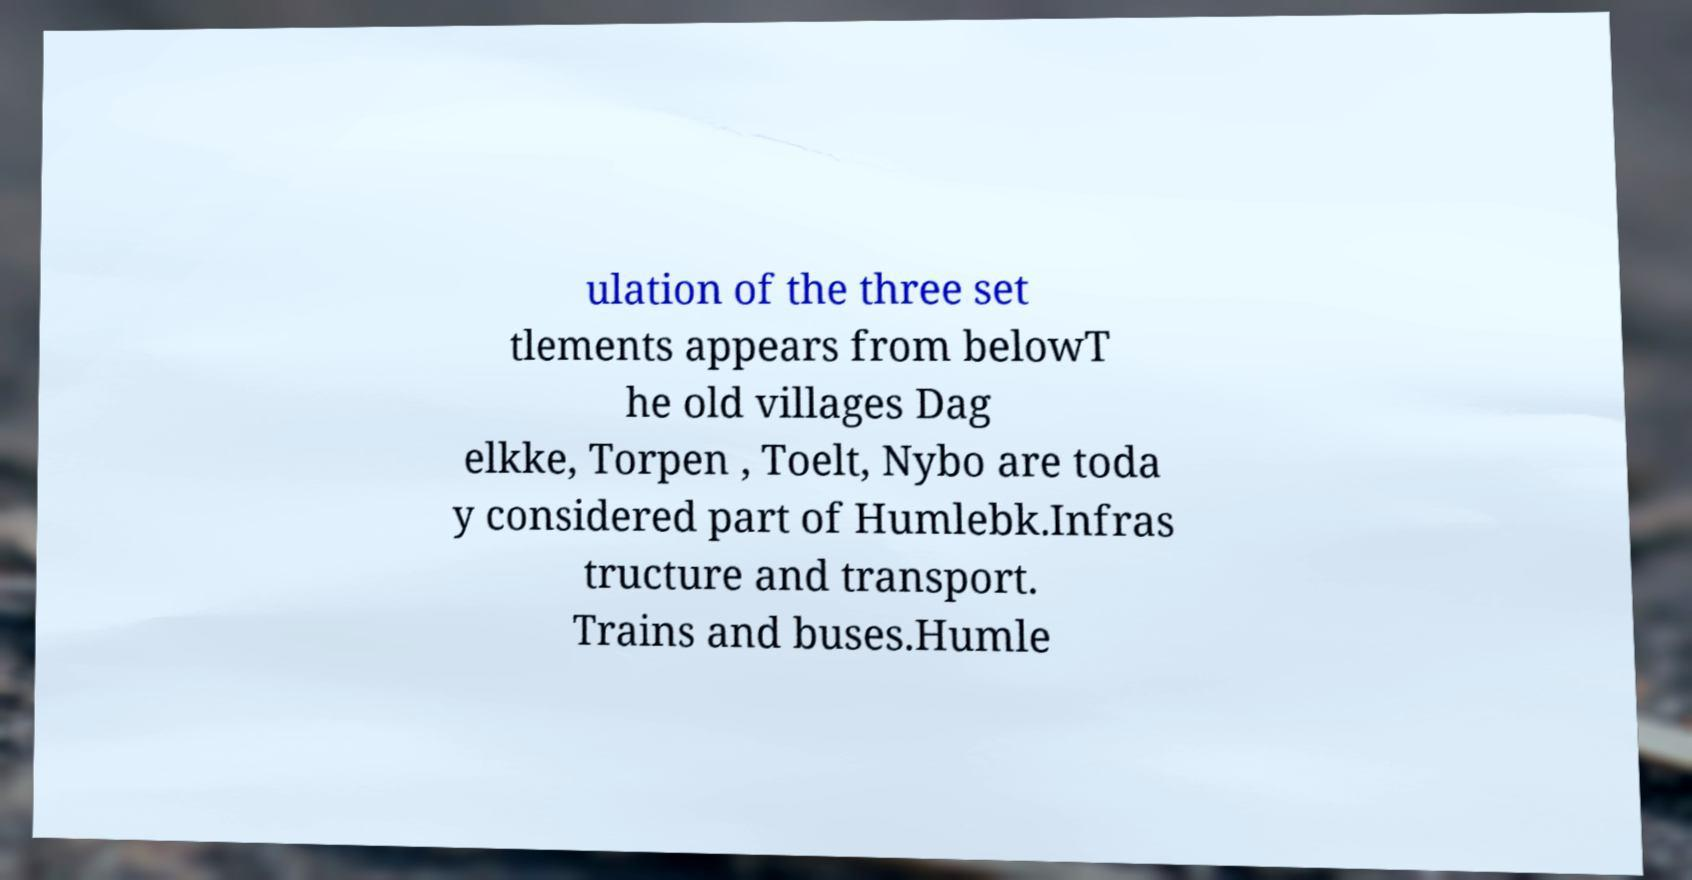Can you accurately transcribe the text from the provided image for me? ulation of the three set tlements appears from belowT he old villages Dag elkke, Torpen , Toelt, Nybo are toda y considered part of Humlebk.Infras tructure and transport. Trains and buses.Humle 